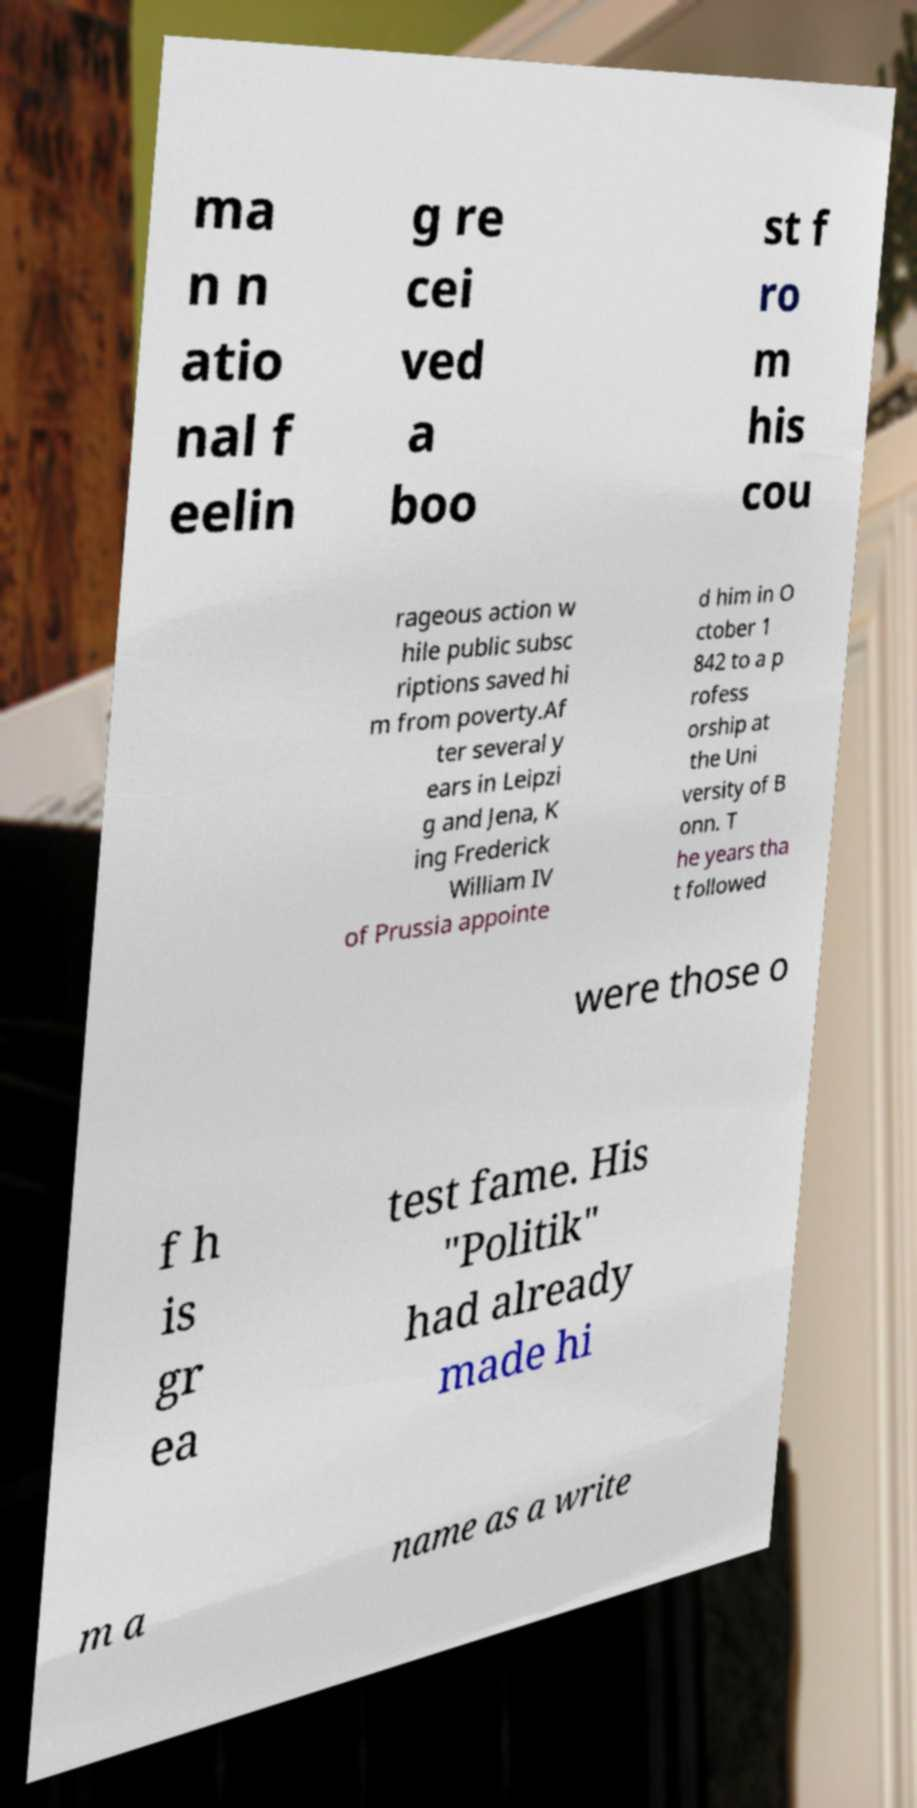For documentation purposes, I need the text within this image transcribed. Could you provide that? ma n n atio nal f eelin g re cei ved a boo st f ro m his cou rageous action w hile public subsc riptions saved hi m from poverty.Af ter several y ears in Leipzi g and Jena, K ing Frederick William IV of Prussia appointe d him in O ctober 1 842 to a p rofess orship at the Uni versity of B onn. T he years tha t followed were those o f h is gr ea test fame. His "Politik" had already made hi m a name as a write 